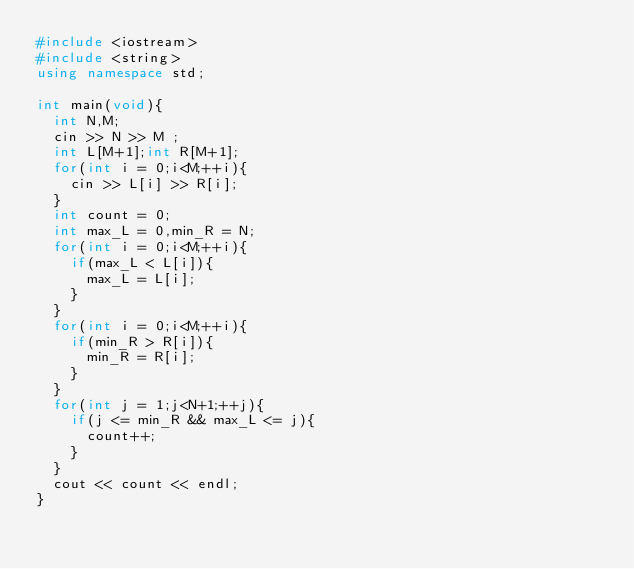Convert code to text. <code><loc_0><loc_0><loc_500><loc_500><_C++_>#include <iostream>
#include <string>
using namespace std;

int main(void){
  int N,M;
  cin >> N >> M ;
  int L[M+1];int R[M+1];
  for(int i = 0;i<M;++i){
    cin >> L[i] >> R[i];
  }
  int count = 0;
  int max_L = 0,min_R = N;
  for(int i = 0;i<M;++i){
    if(max_L < L[i]){
      max_L = L[i];
    }
  }
  for(int i = 0;i<M;++i){
    if(min_R > R[i]){
      min_R = R[i];
    }
  }
  for(int j = 1;j<N+1;++j){
    if(j <= min_R && max_L <= j){
      count++;
    }
  }
  cout << count << endl;    
}</code> 